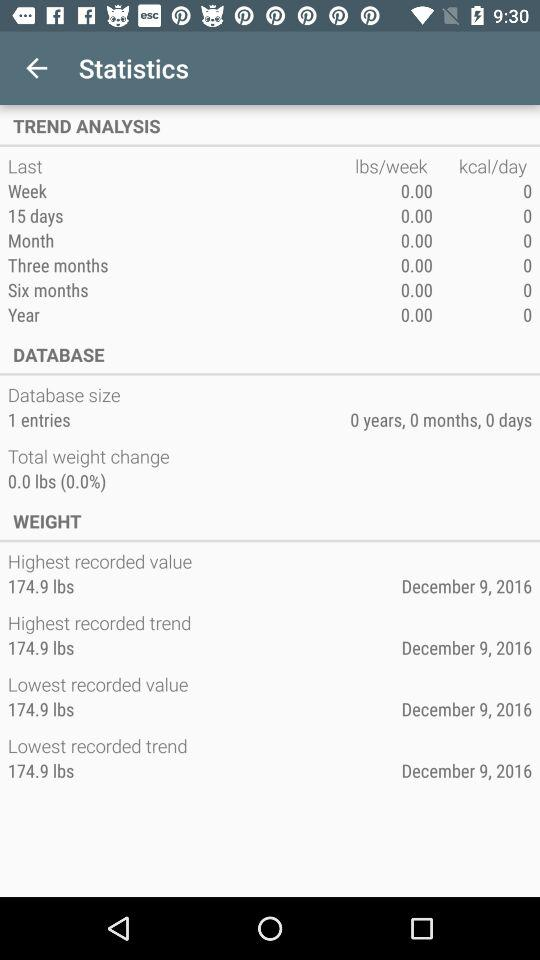What is the number of entries in the database size? The number of entries is 1. 